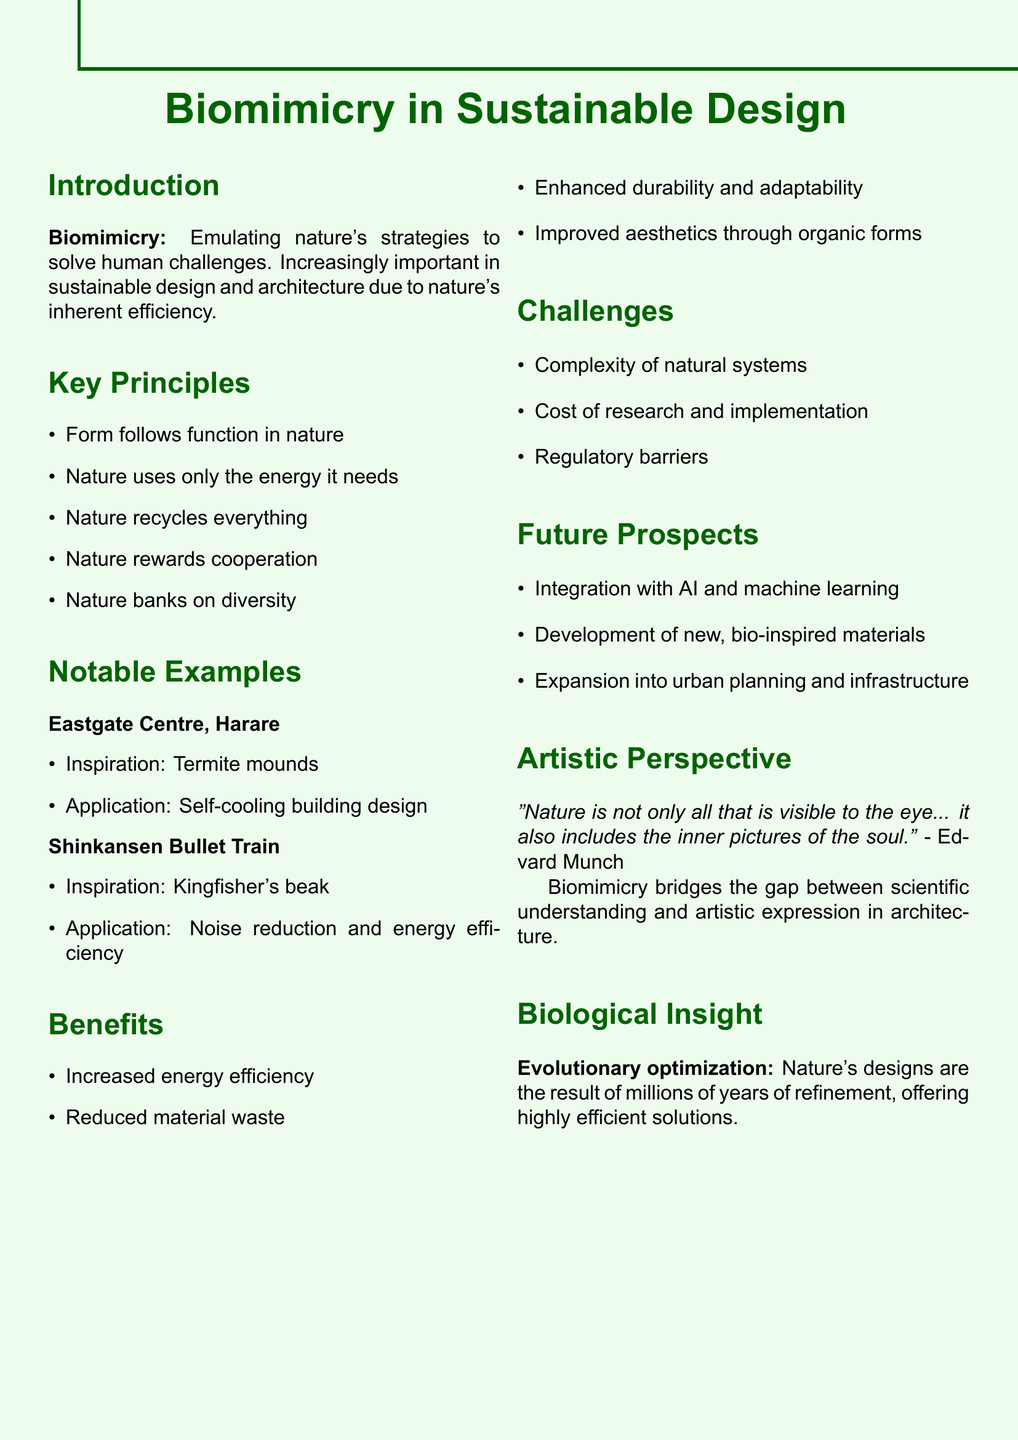What is biomimicry? The document defines biomimicry as the practice of emulating nature's strategies and designs to solve human challenges.
Answer: Emulating nature's strategies What is one key principle of biomimicry? The document lists several key principles; one example is that form follows function in nature.
Answer: Form follows function What inspired the design of the Eastgate Centre? The document states that the inspiration for the Eastgate Centre's design came from termite mounds.
Answer: Termite mounds What are two benefits of biomimicry in design? The document mentions several benefits; two examples are increased energy efficiency and reduced material waste.
Answer: Increased energy efficiency, reduced material waste What challenges does biomimicry face? The document lists challenges such as the complexity of natural systems and the cost of research and implementation.
Answer: Complexity of natural systems, cost of research Who is quoted regarding the artistic perspective of biomimicry? The document attributes a quote about nature to Edvard Munch.
Answer: Edvard Munch What is a future prospect mentioned for biomimicry? The document discusses integration with AI and machine learning as a future prospect for biomimicry.
Answer: Integration with AI and machine learning What does evolutionary optimization refer to? In the document, evolutionary optimization refers to nature's designs resulting from millions of years of refinement.
Answer: Millions of years of refinement 